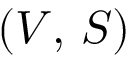<formula> <loc_0><loc_0><loc_500><loc_500>\left ( V , \, S \right )</formula> 